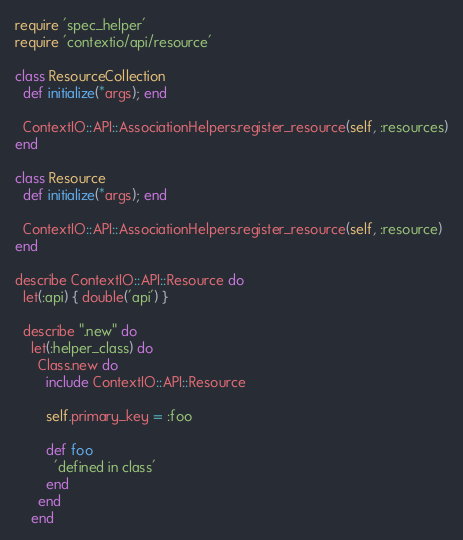Convert code to text. <code><loc_0><loc_0><loc_500><loc_500><_Ruby_>require 'spec_helper'
require 'contextio/api/resource'

class ResourceCollection
  def initialize(*args); end

  ContextIO::API::AssociationHelpers.register_resource(self, :resources)
end

class Resource
  def initialize(*args); end

  ContextIO::API::AssociationHelpers.register_resource(self, :resource)
end

describe ContextIO::API::Resource do
  let(:api) { double('api') }

  describe ".new" do
    let(:helper_class) do
      Class.new do
        include ContextIO::API::Resource

        self.primary_key = :foo

        def foo
          'defined in class'
        end
      end
    end
</code> 